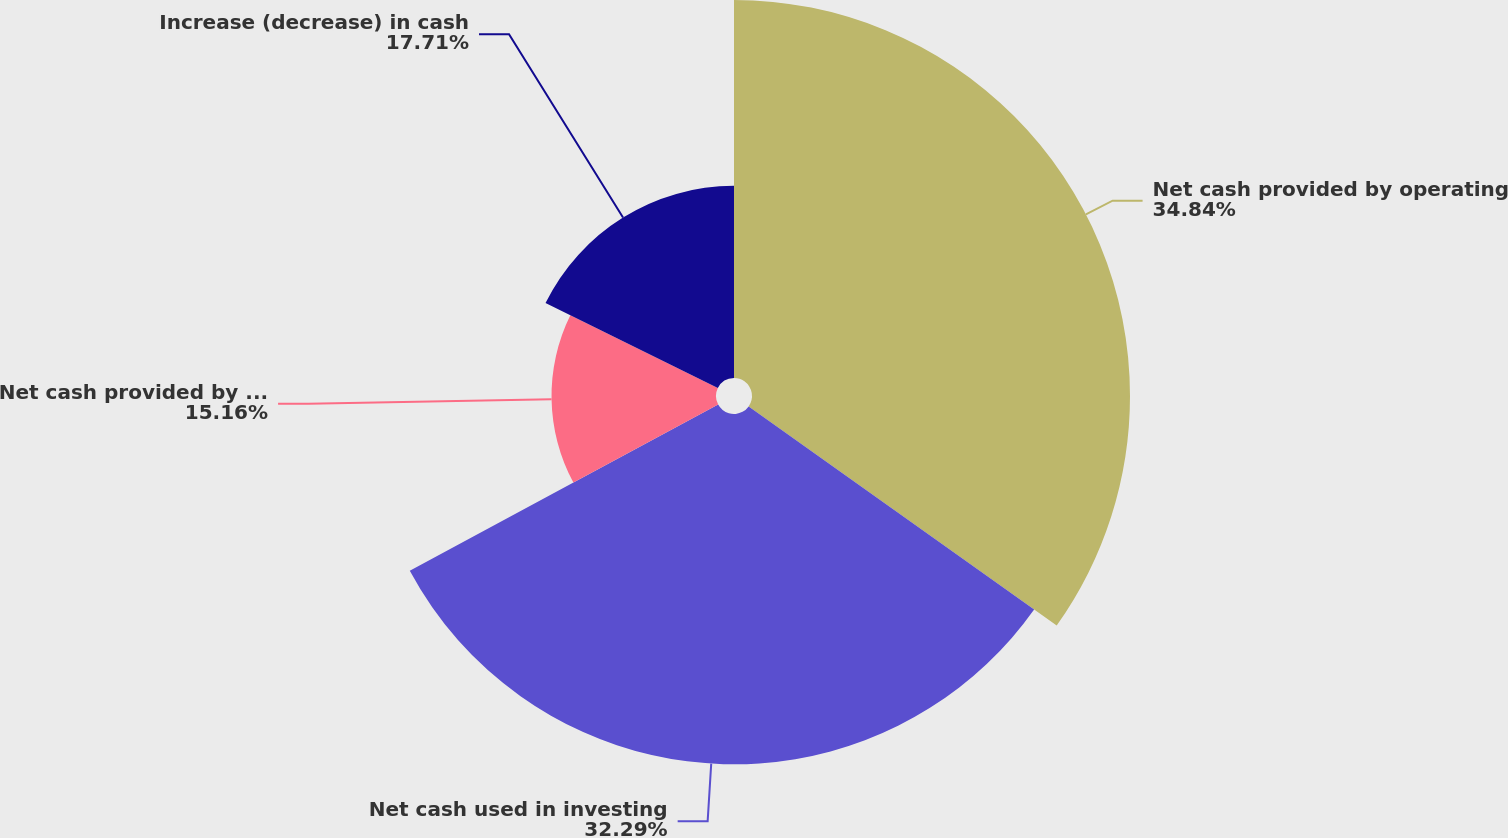Convert chart. <chart><loc_0><loc_0><loc_500><loc_500><pie_chart><fcel>Net cash provided by operating<fcel>Net cash used in investing<fcel>Net cash provided by (used in)<fcel>Increase (decrease) in cash<nl><fcel>34.84%<fcel>32.29%<fcel>15.16%<fcel>17.71%<nl></chart> 